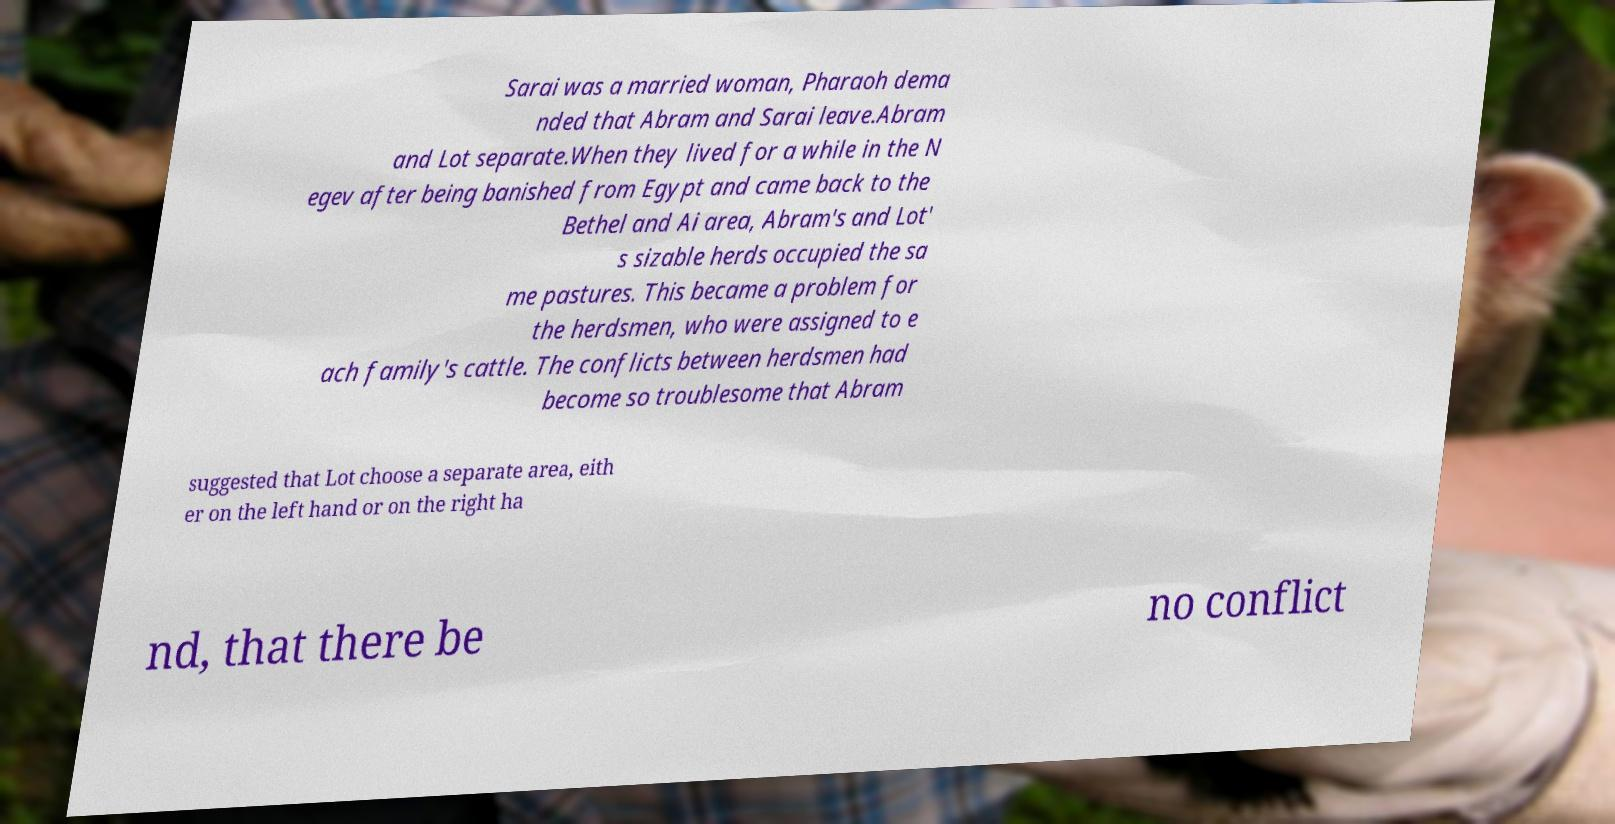For documentation purposes, I need the text within this image transcribed. Could you provide that? Sarai was a married woman, Pharaoh dema nded that Abram and Sarai leave.Abram and Lot separate.When they lived for a while in the N egev after being banished from Egypt and came back to the Bethel and Ai area, Abram's and Lot' s sizable herds occupied the sa me pastures. This became a problem for the herdsmen, who were assigned to e ach family's cattle. The conflicts between herdsmen had become so troublesome that Abram suggested that Lot choose a separate area, eith er on the left hand or on the right ha nd, that there be no conflict 